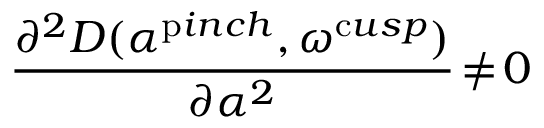Convert formula to latex. <formula><loc_0><loc_0><loc_500><loc_500>\frac { \partial ^ { 2 } D ( \alpha ^ { p i n c h } , \omega ^ { c u s p } ) } { \partial \alpha ^ { 2 } } \, \ne \, 0</formula> 